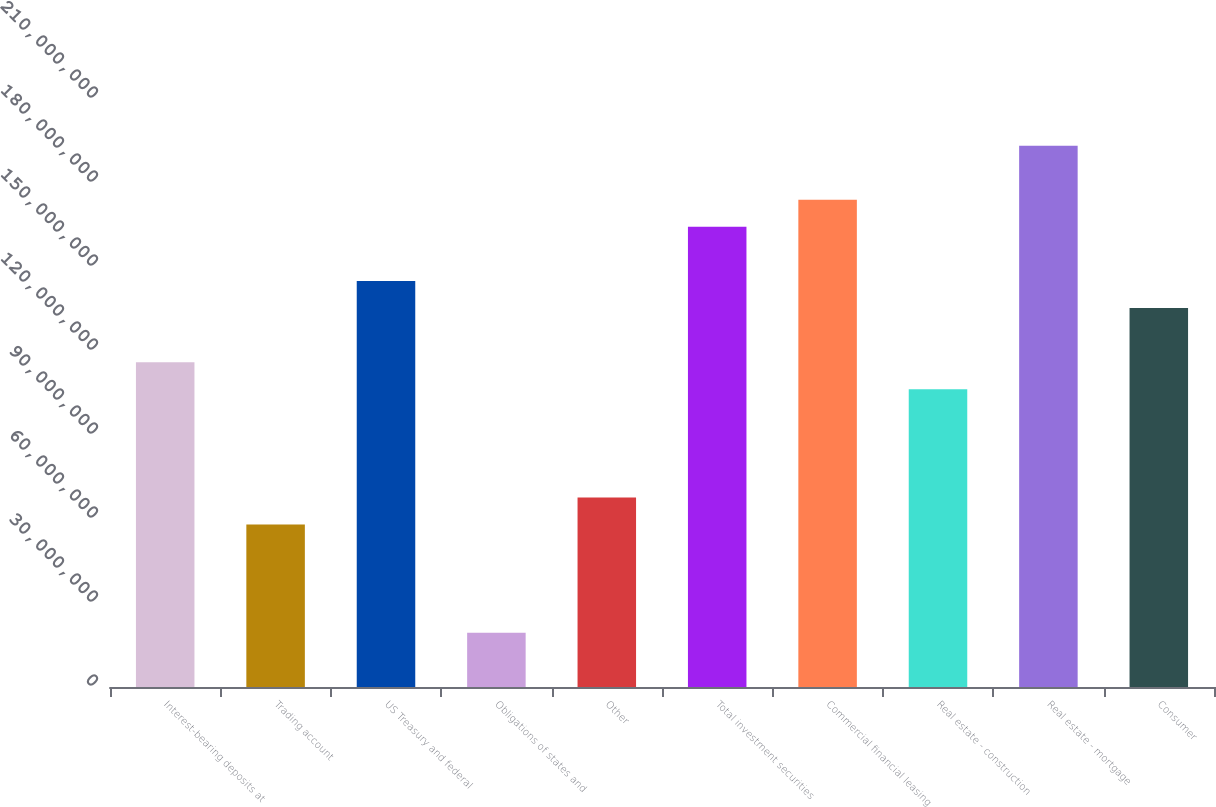Convert chart to OTSL. <chart><loc_0><loc_0><loc_500><loc_500><bar_chart><fcel>Interest-bearing deposits at<fcel>Trading account<fcel>US Treasury and federal<fcel>Obligations of states and<fcel>Other<fcel>Total investment securities<fcel>Commercial financial leasing<fcel>Real estate - construction<fcel>Real estate - mortgage<fcel>Consumer<nl><fcel>1.16016e+08<fcel>5.80253e+07<fcel>1.45011e+08<fcel>1.93651e+07<fcel>6.76904e+07<fcel>1.64341e+08<fcel>1.74006e+08<fcel>1.06351e+08<fcel>1.93336e+08<fcel>1.35346e+08<nl></chart> 